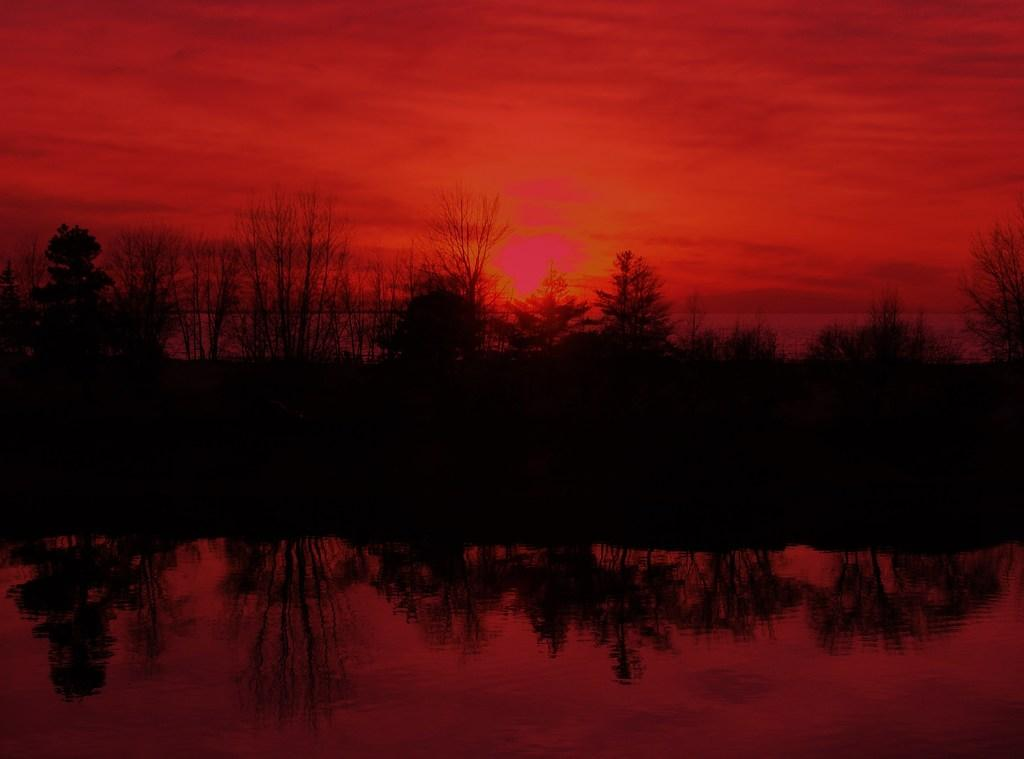What is the primary element visible in the image? There is a water surface in the image. What can be seen in the background of the image? There are trees in the background of the image. What is the color of the sky in the image? The sky appears red in the image. What type of line can be seen running through the grass in the image? There is no grass present in the image, and therefore no line running through it. 